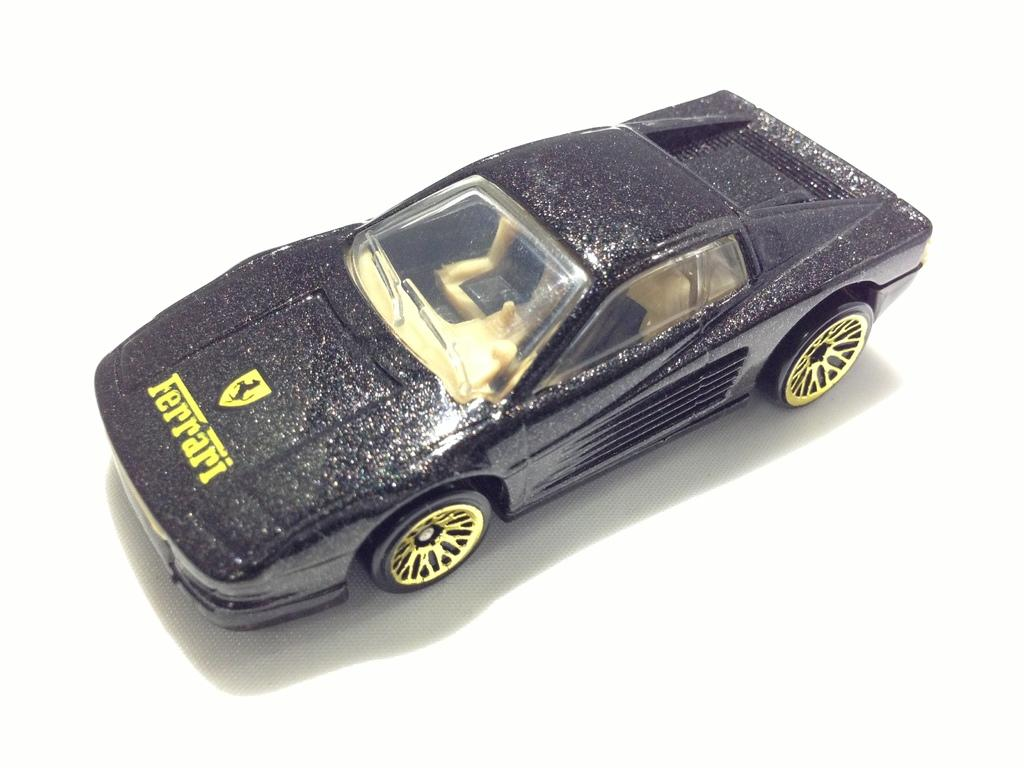What is the main subject of the image? The main subject of the image is a toy car. Can you describe the appearance of the toy car? The toy car is black and yellow in color. What is the toy car placed on in the image? The toy car is on a white surface. Are there any cats visible in the image, interacting with the toy car? There are no cats present in the image, and the toy car is not interacting with any animals. 